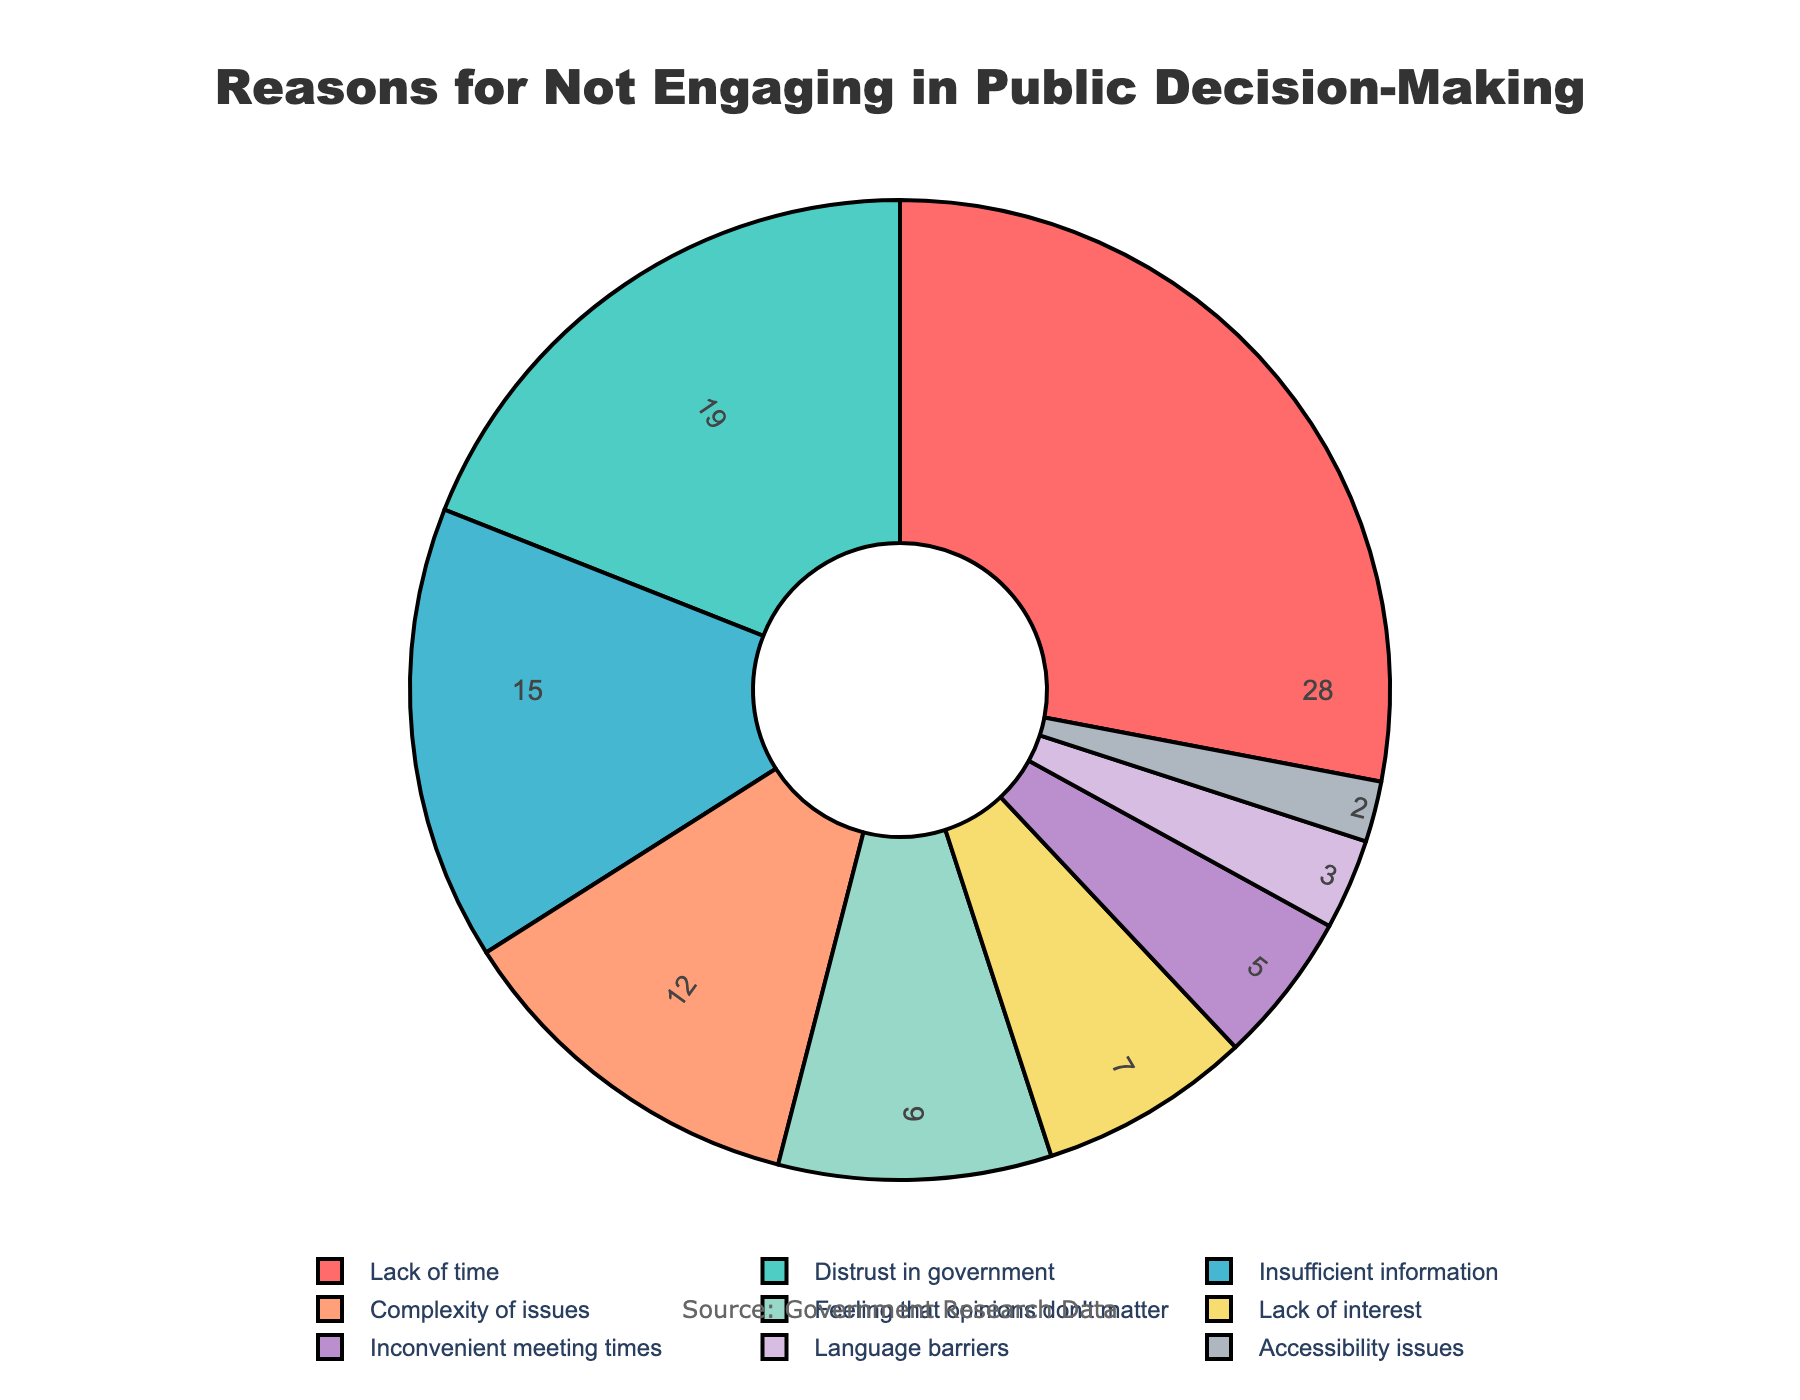what's the total percentage of reasons cited by citizens for not engaging that are related to time or scheduling? Identify categories related to time or scheduling: "Lack of time" (28%) and "Inconvenient meeting times" (5%). Sum these percentages: 28 + 5 = 33
Answer: 33 what's the difference in percentage between the top and bottom reasons for not engaging? Identify the top reason: "Lack of time" (28%) and the bottom reason: "Accessibility issues" (2%). Compute the difference: 28 - 2 = 26
Answer: 26 which reason is cited more often: "Distrust in government" or "Insufficient information"? Compare the percentages: "Distrust in government" (19%) vs "Insufficient information" (15%). 19 is greater than 15, so "Distrust in government" is cited more often
Answer: Distrust in government what percentage is attributed to "Lack of interest" and "Feeling that opinions don't matter" combined? Identify percentages: "Lack of interest" (7%) and "Feeling that opinions don't matter" (9%). Sum these percentages: 7 + 9 = 16
Answer: 16 among the reasons, which one has the second lowest percentage? Order the percentages from lowest to highest and identify the second lowest: "Accessibility issues" (2%), "Language barriers" (3%). So, "Language barriers" has the second lowest percentage
Answer: Language barriers what is the approximate average percentage of all the reasons cited? Sum all percentages: 28 + 19 + 15 + 12 + 9 + 7 + 5 + 3 + 2 = 100. Divide by the number of reasons (9): 100 / 9 ≈ 11.1
Answer: 11.1 which three reasons have the highest percentages, and what is their combined total? Identify top three percentages: "Lack of time" (28%), "Distrust in government" (19%), and "Insufficient information" (15%). Sum these percentages: 28 + 19 + 15 = 62
Answer: 62 what color is used to represent the "Complexity of issues" in the pie chart? Visually locate the segment labeled "Complexity of issues" and identify its color based on the provided color scheme. It is represented by the fourth color in the list, which is a salmon-like color
Answer: salmon-like color 